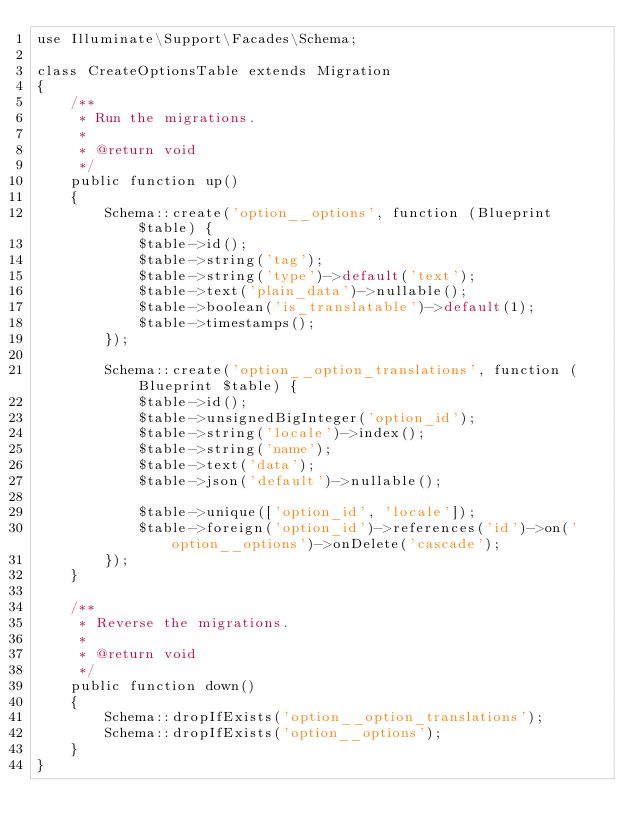Convert code to text. <code><loc_0><loc_0><loc_500><loc_500><_PHP_>use Illuminate\Support\Facades\Schema;

class CreateOptionsTable extends Migration
{
    /**
     * Run the migrations.
     *
     * @return void
     */
    public function up()
    {
        Schema::create('option__options', function (Blueprint $table) {
            $table->id();
            $table->string('tag');
            $table->string('type')->default('text');
            $table->text('plain_data')->nullable();
            $table->boolean('is_translatable')->default(1);
            $table->timestamps();
        });

        Schema::create('option__option_translations', function (Blueprint $table) {
            $table->id();
            $table->unsignedBigInteger('option_id');
            $table->string('locale')->index();
            $table->string('name');
            $table->text('data');
            $table->json('default')->nullable();

            $table->unique(['option_id', 'locale']);
            $table->foreign('option_id')->references('id')->on('option__options')->onDelete('cascade');
        });
    }

    /**
     * Reverse the migrations.
     *
     * @return void
     */
    public function down()
    {
        Schema::dropIfExists('option__option_translations');
        Schema::dropIfExists('option__options');
    }
}
</code> 